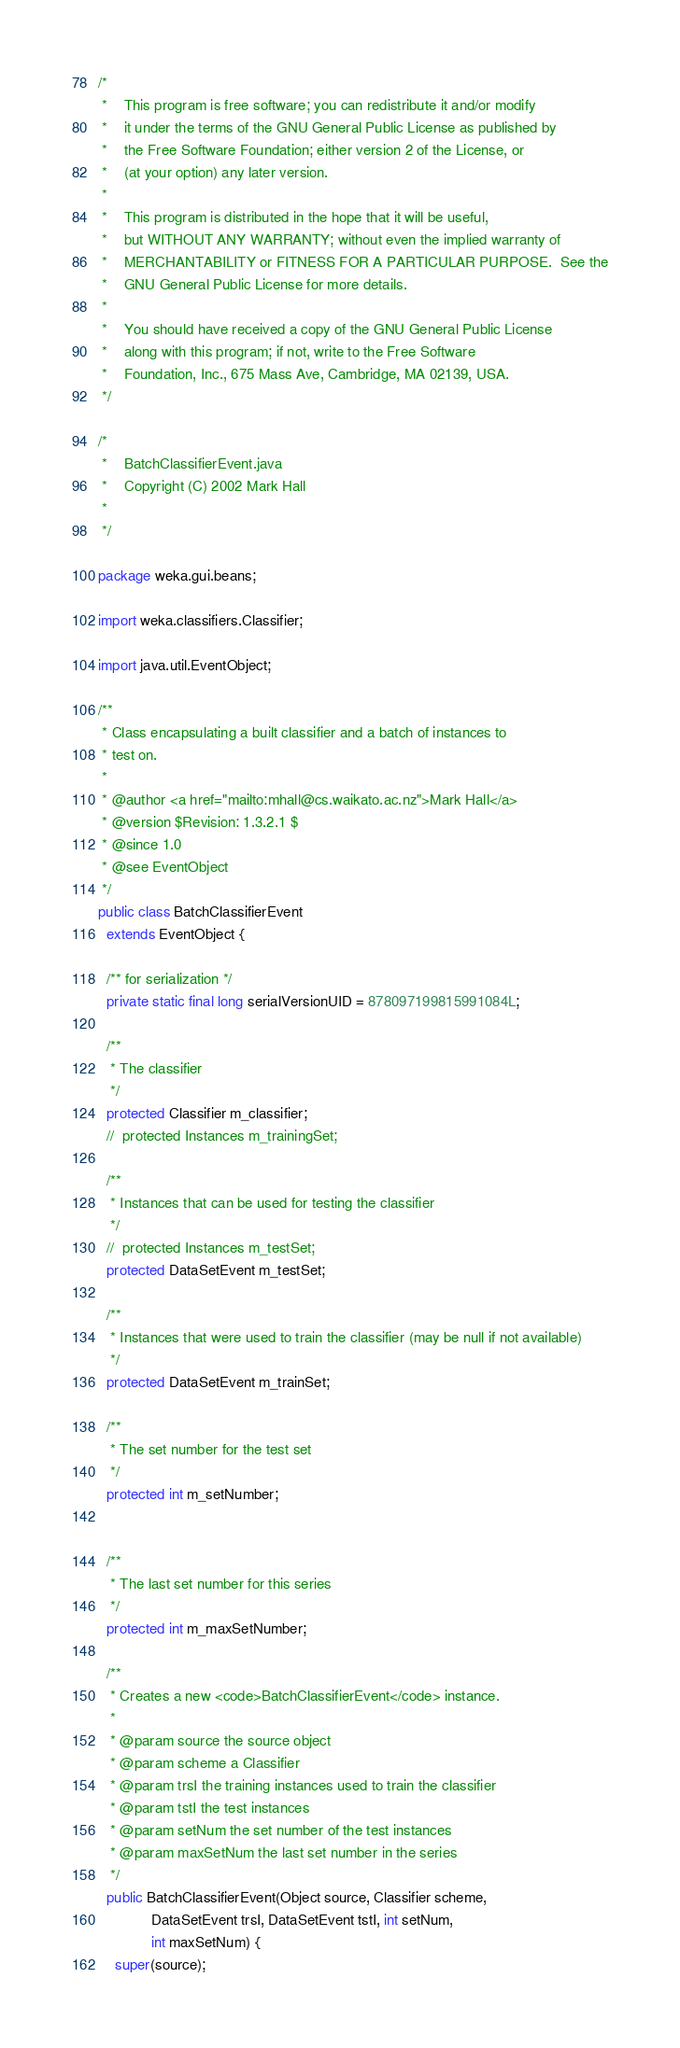<code> <loc_0><loc_0><loc_500><loc_500><_Java_>/*
 *    This program is free software; you can redistribute it and/or modify
 *    it under the terms of the GNU General Public License as published by
 *    the Free Software Foundation; either version 2 of the License, or
 *    (at your option) any later version.
 *
 *    This program is distributed in the hope that it will be useful,
 *    but WITHOUT ANY WARRANTY; without even the implied warranty of
 *    MERCHANTABILITY or FITNESS FOR A PARTICULAR PURPOSE.  See the
 *    GNU General Public License for more details.
 *
 *    You should have received a copy of the GNU General Public License
 *    along with this program; if not, write to the Free Software
 *    Foundation, Inc., 675 Mass Ave, Cambridge, MA 02139, USA.
 */

/*
 *    BatchClassifierEvent.java
 *    Copyright (C) 2002 Mark Hall
 *
 */

package weka.gui.beans;

import weka.classifiers.Classifier;

import java.util.EventObject;

/**
 * Class encapsulating a built classifier and a batch of instances to
 * test on.
 *
 * @author <a href="mailto:mhall@cs.waikato.ac.nz">Mark Hall</a>
 * @version $Revision: 1.3.2.1 $
 * @since 1.0
 * @see EventObject
 */
public class BatchClassifierEvent
  extends EventObject {

  /** for serialization */
  private static final long serialVersionUID = 878097199815991084L;

  /**
   * The classifier
   */
  protected Classifier m_classifier;
  //  protected Instances m_trainingSet;

  /**
   * Instances that can be used for testing the classifier
   */
  //  protected Instances m_testSet;
  protected DataSetEvent m_testSet;
  
  /**
   * Instances that were used to train the classifier (may be null if not available)
   */
  protected DataSetEvent m_trainSet;

  /**
   * The set number for the test set
   */
  protected int m_setNumber;


  /**
   * The last set number for this series
   */
  protected int m_maxSetNumber;

  /**
   * Creates a new <code>BatchClassifierEvent</code> instance.
   *
   * @param source the source object
   * @param scheme a Classifier
   * @param trsI the training instances used to train the classifier
   * @param tstI the test instances
   * @param setNum the set number of the test instances
   * @param maxSetNum the last set number in the series
   */
  public BatchClassifierEvent(Object source, Classifier scheme,
			 DataSetEvent trsI, DataSetEvent tstI, int setNum,
			 int maxSetNum) {
    super(source);</code> 